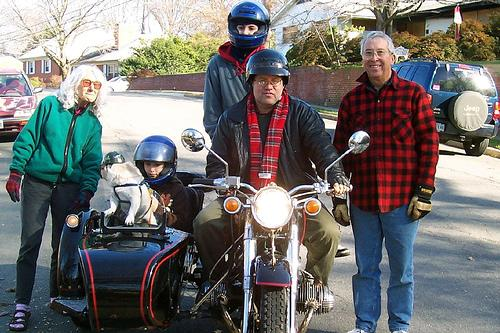What is the little dog wearing in the sidecar? helmet 